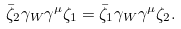<formula> <loc_0><loc_0><loc_500><loc_500>\bar { \zeta } _ { 2 } \gamma _ { W } \gamma ^ { \mu } \zeta _ { 1 } = \bar { \zeta } _ { 1 } \gamma _ { W } \gamma ^ { \mu } \zeta _ { 2 } .</formula> 